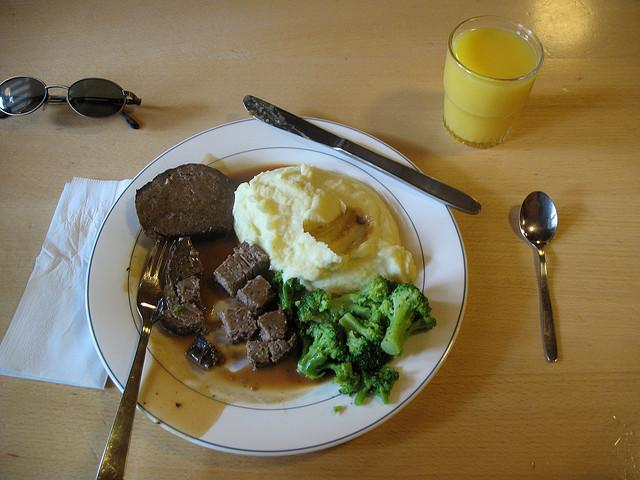Which food on the plate is highest carbohydrates? potatoes 